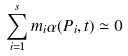<formula> <loc_0><loc_0><loc_500><loc_500>\sum _ { i = 1 } ^ { s } m _ { i } \alpha ( P _ { i } , t ) \simeq 0</formula> 